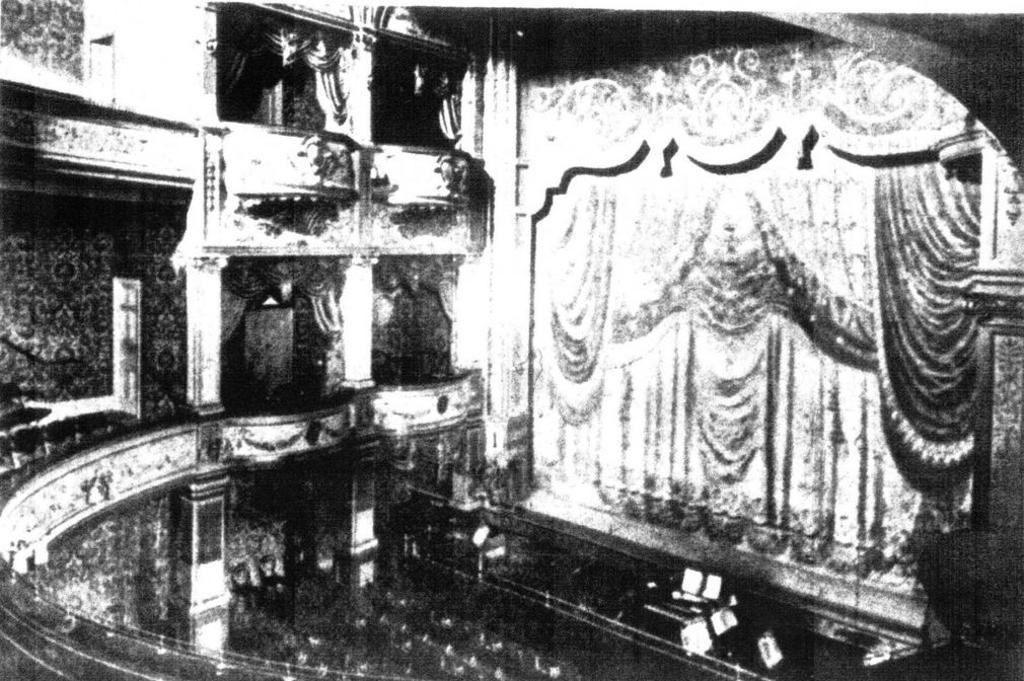What is the color scheme of the image? The image is black and white. Where was the image likely taken? The image was likely taken inside a building. What type of window treatment can be seen in the image? There are curtains hanging in the image. What architectural features are visible in the image? There are pillars visible in the image. What type of setting is depicted in the image? The scene appears to be a stage. Is there a hose visible on the stage in the image? No, there is no hose present in the image. What type of watch is the actor wearing on stage? There are no actors or watches visible in the image; it only shows a stage with curtains and pillars. 